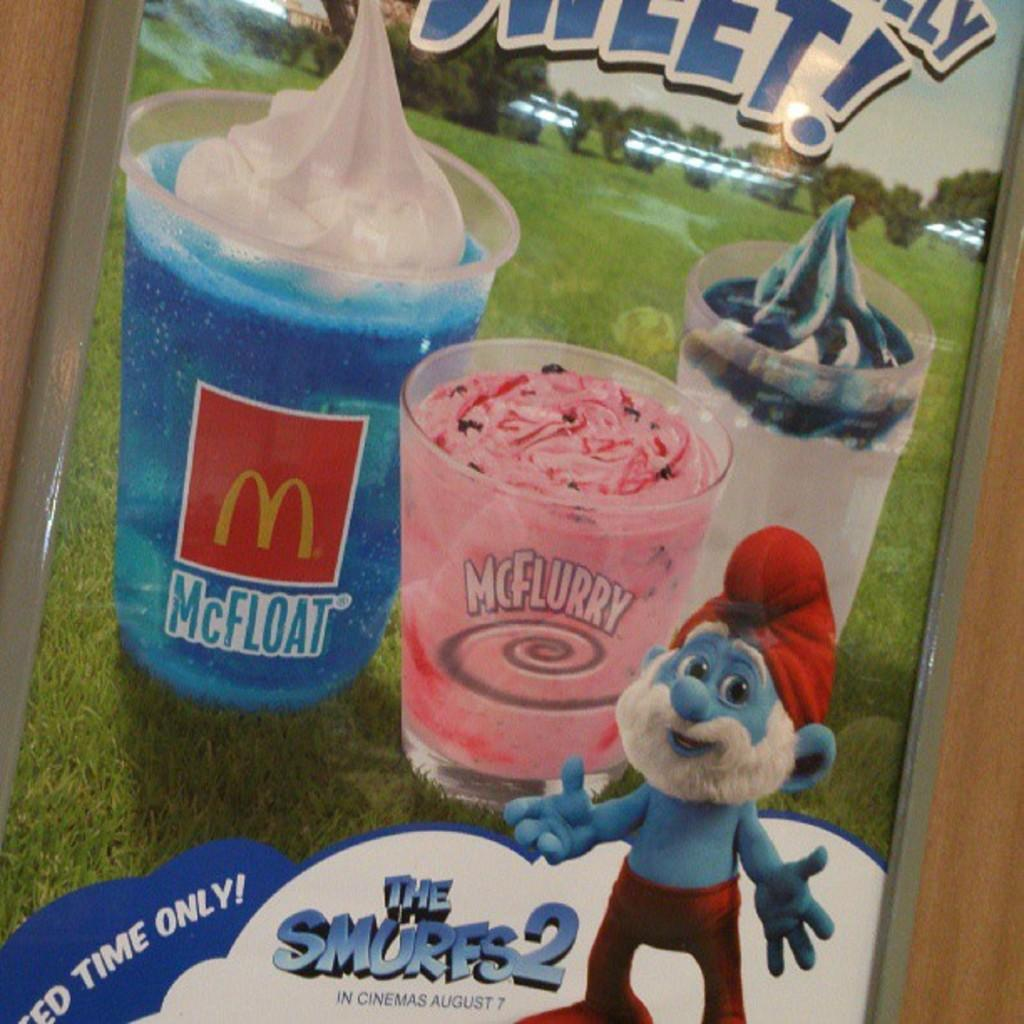What object in the image contains three glasses? The photo frame in the image contains three glasses. What type of vegetation is visible in the image? Grass and trees are present in the image. Is there any text in the image? Yes, there is some text in the image. What is depicted in the photo frame? A cartoon image is present in the photo frame. What type of surface is visible in the background of the image? There is a wooden surface in the background of the image. What type of feeling is expressed by the trees in the image? The trees in the image do not express any feelings, as they are inanimate objects. What scientific experiment is being conducted in the image? There is no scientific experiment being conducted in the image. What time of day is depicted in the image? The time of day is not specified in the image. 